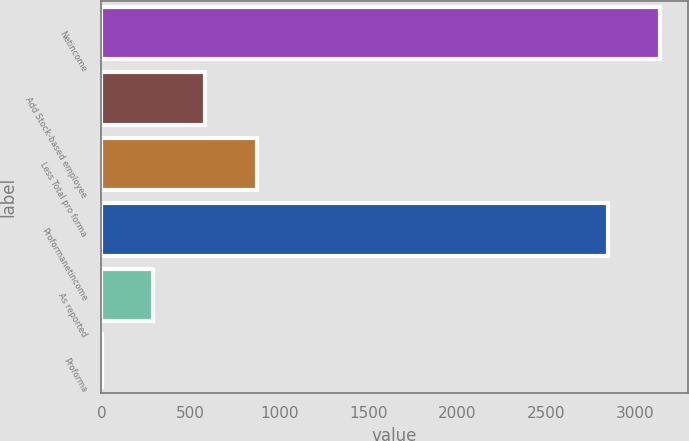Convert chart. <chart><loc_0><loc_0><loc_500><loc_500><bar_chart><fcel>Netincome<fcel>Add Stock-based employee<fcel>Less Total pro forma<fcel>Proformanetincome<fcel>As reported<fcel>Proforma<nl><fcel>3136.55<fcel>581.6<fcel>871.15<fcel>2847<fcel>292.05<fcel>2.5<nl></chart> 